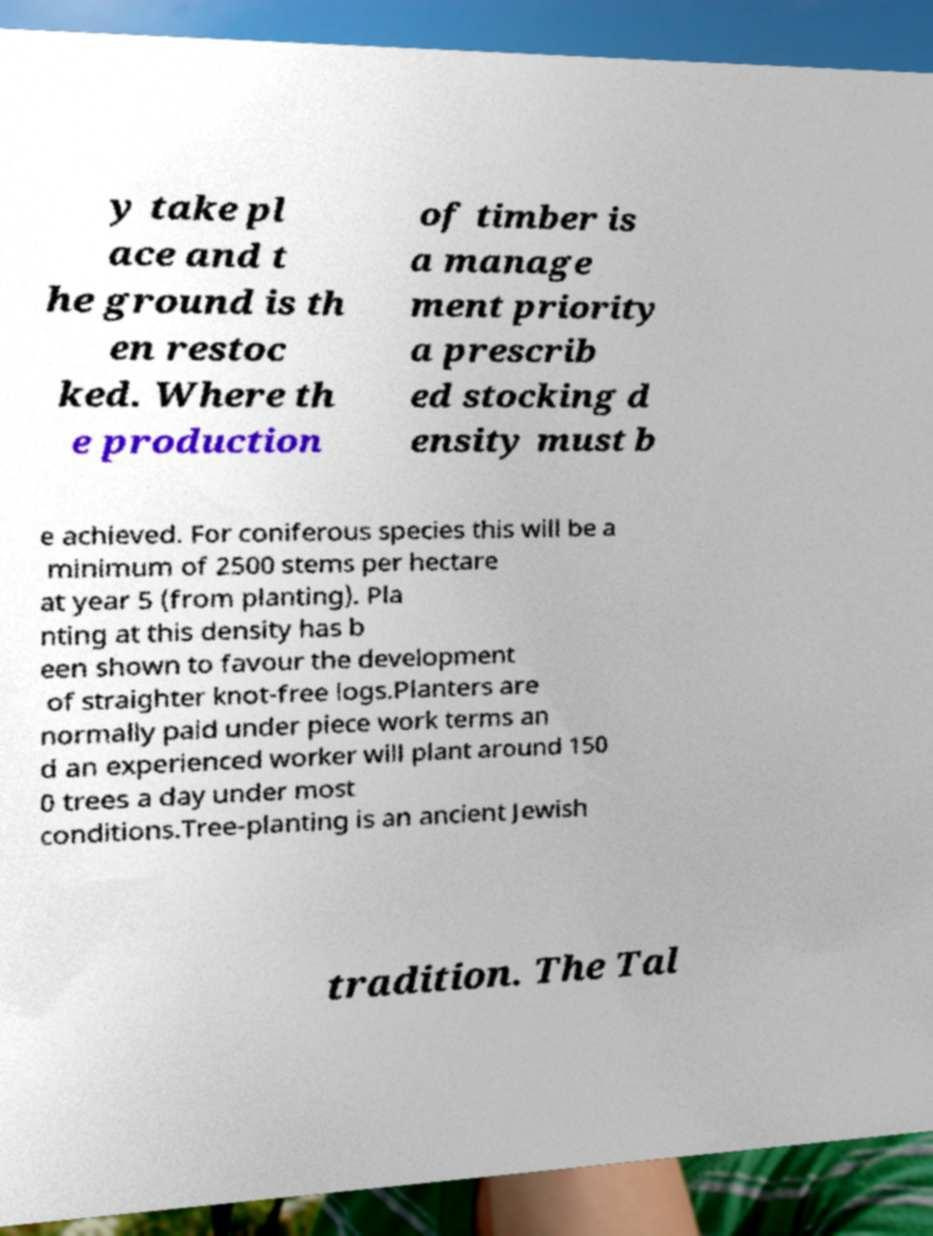For documentation purposes, I need the text within this image transcribed. Could you provide that? y take pl ace and t he ground is th en restoc ked. Where th e production of timber is a manage ment priority a prescrib ed stocking d ensity must b e achieved. For coniferous species this will be a minimum of 2500 stems per hectare at year 5 (from planting). Pla nting at this density has b een shown to favour the development of straighter knot-free logs.Planters are normally paid under piece work terms an d an experienced worker will plant around 150 0 trees a day under most conditions.Tree-planting is an ancient Jewish tradition. The Tal 